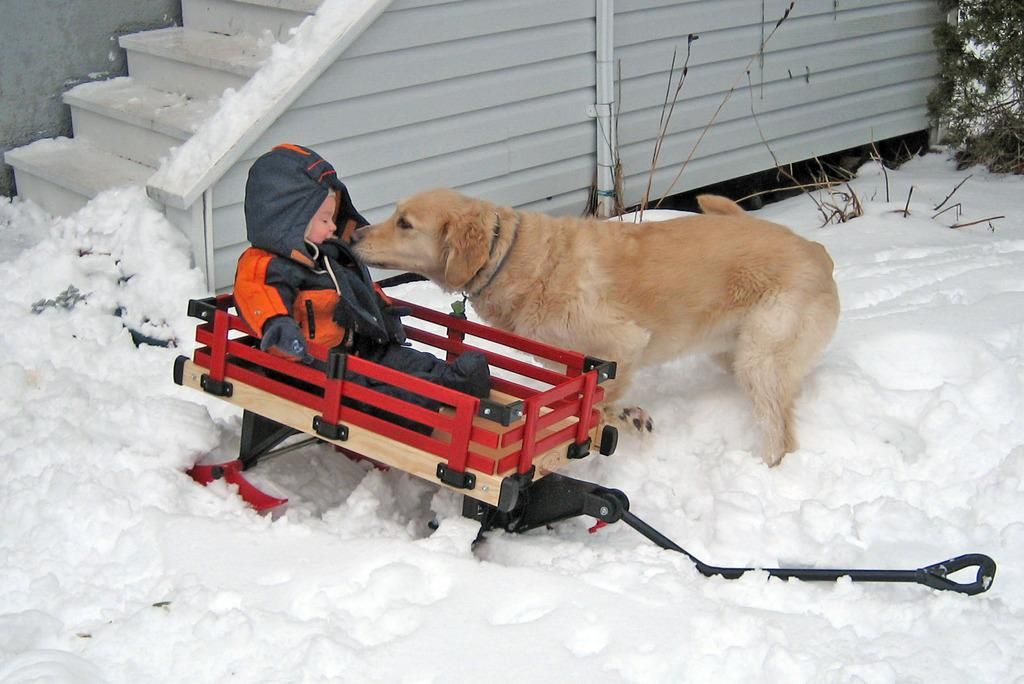What is the kid doing in the image? The kid is sitting on a trolley in the image. What other living creature is present in the image? There is a dog in the image. What type of vegetation can be seen in the image? There is a plant in the image. What architectural feature is visible in the image? There is a staircase in the image. What is the weather like in the image? There is snow visible in the image, indicating a cold or wintry environment. What is the background of the image made of? There is a wall in the image. What type of fowl can be seen walking on the staircase in the image? There is no fowl present in the image; only a kid, a dog, a plant, a staircase, snow, and a wall are visible. How many beans are visible in the image? There are no beans present in the image. 